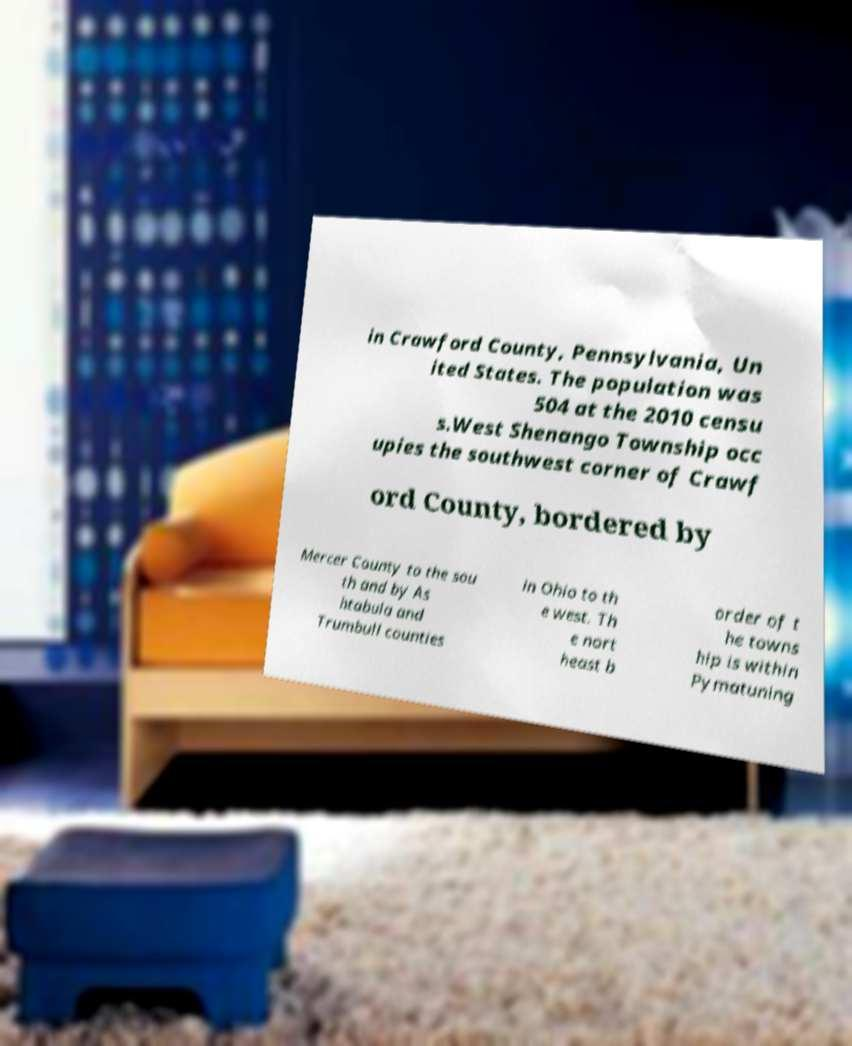Please read and relay the text visible in this image. What does it say? in Crawford County, Pennsylvania, Un ited States. The population was 504 at the 2010 censu s.West Shenango Township occ upies the southwest corner of Crawf ord County, bordered by Mercer County to the sou th and by As htabula and Trumbull counties in Ohio to th e west. Th e nort heast b order of t he towns hip is within Pymatuning 